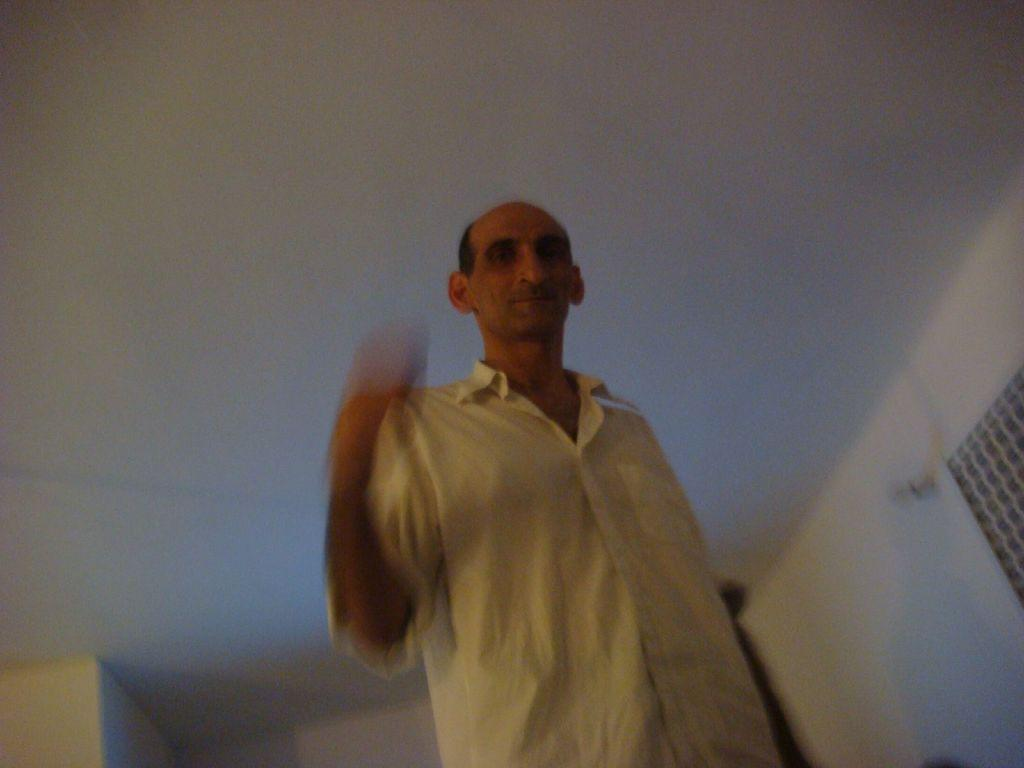Who is present in the image? There is a man in the image. What is the man wearing? The man is wearing a shirt. Can you describe the quality of the image? The image is blurred in some areas. What can be seen in the background of the image? There is a white wall in the background of the image. What type of nut is the man cracking on the table in the image? There is no nut or table present in the image; it only features a man wearing a shirt in front of a white wall. 